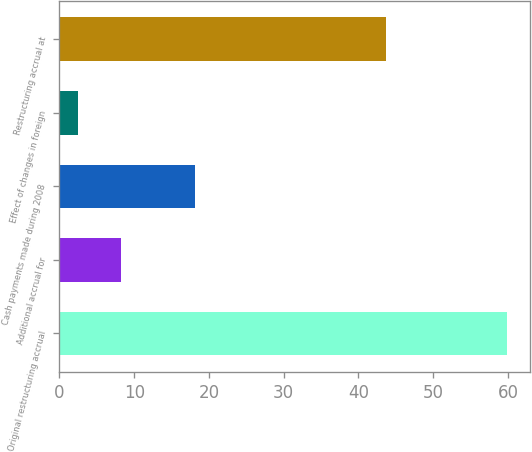Convert chart. <chart><loc_0><loc_0><loc_500><loc_500><bar_chart><fcel>Original restructuring accrual<fcel>Additional accrual for<fcel>Cash payments made during 2008<fcel>Effect of changes in foreign<fcel>Restructuring accrual at<nl><fcel>59.9<fcel>8.24<fcel>18.1<fcel>2.5<fcel>43.7<nl></chart> 